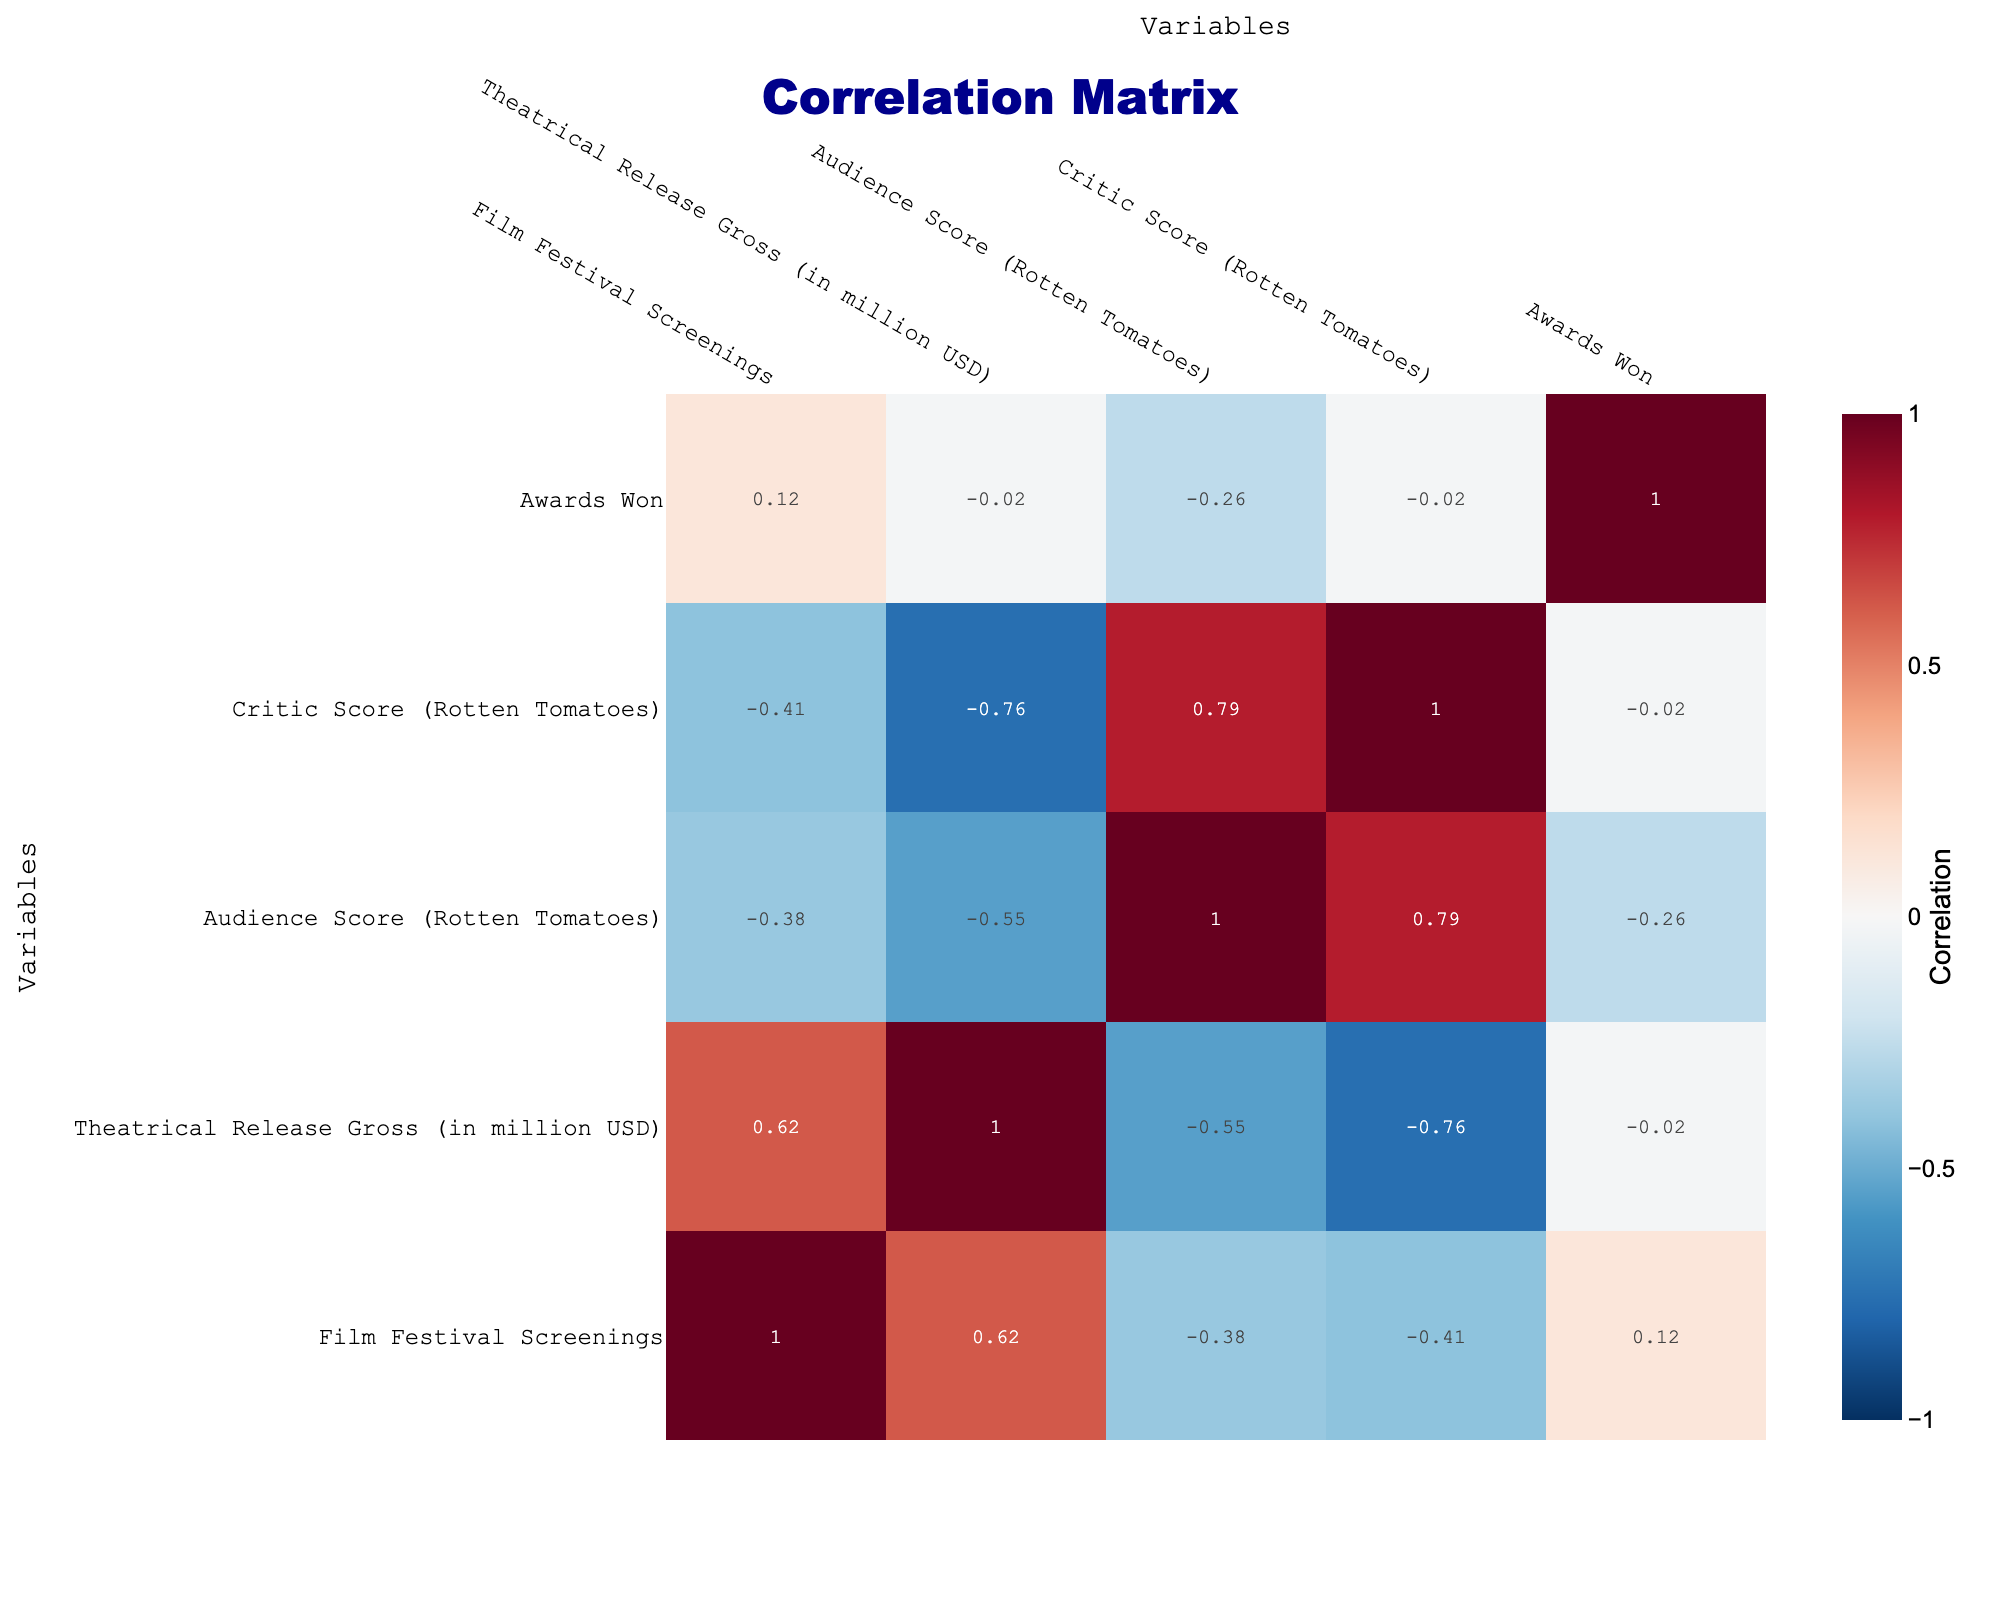What is the highest theatrical release gross among the films listed? To find the highest theatrical release gross, we look for the maximum value in the "Theatrical Release Gross (in million USD)" column. The maximum value is 1074 million USD from the film "Joker".
Answer: 1074 million USD How many films have more than 10 film festival screenings? By examining the "Film Festival Screenings" column, we see that "Parasite", "Moonlight", "Joker", and "Once Upon a Time in Hollywood" have more than 10 festival screenings. There are four films in total that meet this criterion.
Answer: 4 What is the average audience score of films that won awards? The films that won awards are "Parasite", "Moonlight", "Lady Bird", "The Shape of Water", "Whiplash", "Get Out", "Green Book", "Joker", "Roma", and "Once Upon a Time in Hollywood". Their audience scores are 98, 98, 80, 72, 94, 98, 77, 68, 95, and 70. The average audience score is calculated as follows: (98 + 98 + 80 + 72 + 94 + 98 + 77 + 68 + 95 + 70) / 10 = 85.9.
Answer: 85.9 Is there any film with a theatrical release gross of less than 20 million USD? By checking the "Theatrical Release Gross (in million USD)" column, we find that "The Florida Project" has a gross of 11 million USD, which is less than 20 million USD.
Answer: Yes What is the correlation between the number of film festival screenings and the theatrical release gross? To find the correlation, we look at the correlation matrix, which shows that the correlation between "Film Festival Screenings" and "Theatrical Release Gross (in million USD)" is approximately 0.68. This indicates a strong positive correlation, suggesting that as the number of film festival screenings increases, the theatrical release gross also tends to increase.
Answer: 0.68 What is the difference in gross between the highest-grossing film and the lowest-grossing film? The highest-grossing film is "Joker" with a gross of 1074 million USD, while the lowest is "The Florida Project" with a gross of 11 million USD. The difference is calculated as 1074 - 11 = 1063 million USD.
Answer: 1063 million USD Which film has the lowest critic score among those listed? Looking through the "Critic Score (Rotten Tomatoes)" column, "Joker" has the lowest score at 68, compared to other films listed.
Answer: Joker How does the audience score of "Nomadland" compare to the average audience score of the other films? The audience score of "Nomadland" is 85. To find the average, we take the audience scores of the other films: (98 + 98 + 80 + 72 + 94 + 95 + 98 + 77 + 68 + 95 + 70) / 11 = 85.45. Comparing it to "Nomadland" (85), it is slightly lower.
Answer: Slightly lower What is the total number of awards won by films screened at festivals fewer than 7 times? The films with fewer than 7 festival screenings are "The Florida Project", "Nomadland", "Get Out", and "The Farewell" which won 1, 3, 1, and 1 awards respectively. The total awards won is 1 + 3 + 1 + 1 = 6.
Answer: 6 